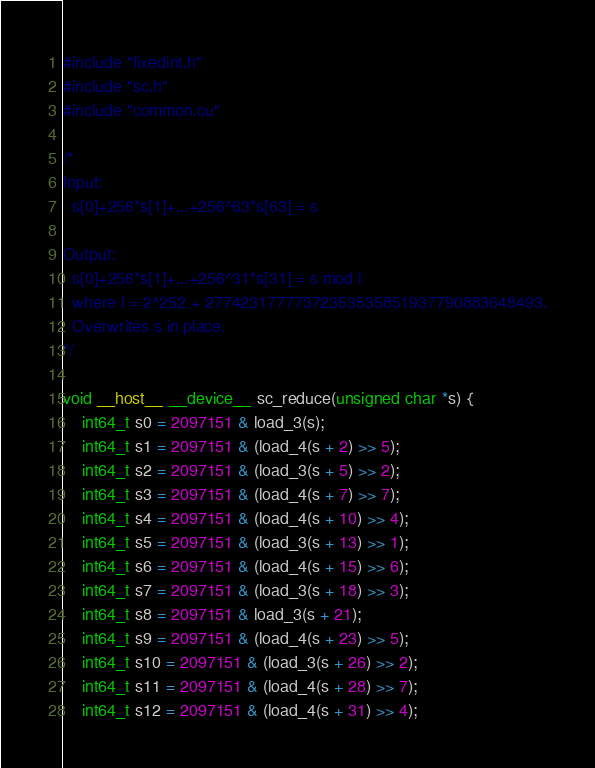Convert code to text. <code><loc_0><loc_0><loc_500><loc_500><_Cuda_>#include "fixedint.h"
#include "sc.h"
#include "common.cu"

/*
Input:
  s[0]+256*s[1]+...+256^63*s[63] = s

Output:
  s[0]+256*s[1]+...+256^31*s[31] = s mod l
  where l = 2^252 + 27742317777372353535851937790883648493.
  Overwrites s in place.
*/

void __host__ __device__ sc_reduce(unsigned char *s) {
    int64_t s0 = 2097151 & load_3(s);
    int64_t s1 = 2097151 & (load_4(s + 2) >> 5);
    int64_t s2 = 2097151 & (load_3(s + 5) >> 2);
    int64_t s3 = 2097151 & (load_4(s + 7) >> 7);
    int64_t s4 = 2097151 & (load_4(s + 10) >> 4);
    int64_t s5 = 2097151 & (load_3(s + 13) >> 1);
    int64_t s6 = 2097151 & (load_4(s + 15) >> 6);
    int64_t s7 = 2097151 & (load_3(s + 18) >> 3);
    int64_t s8 = 2097151 & load_3(s + 21);
    int64_t s9 = 2097151 & (load_4(s + 23) >> 5);
    int64_t s10 = 2097151 & (load_3(s + 26) >> 2);
    int64_t s11 = 2097151 & (load_4(s + 28) >> 7);
    int64_t s12 = 2097151 & (load_4(s + 31) >> 4);</code> 